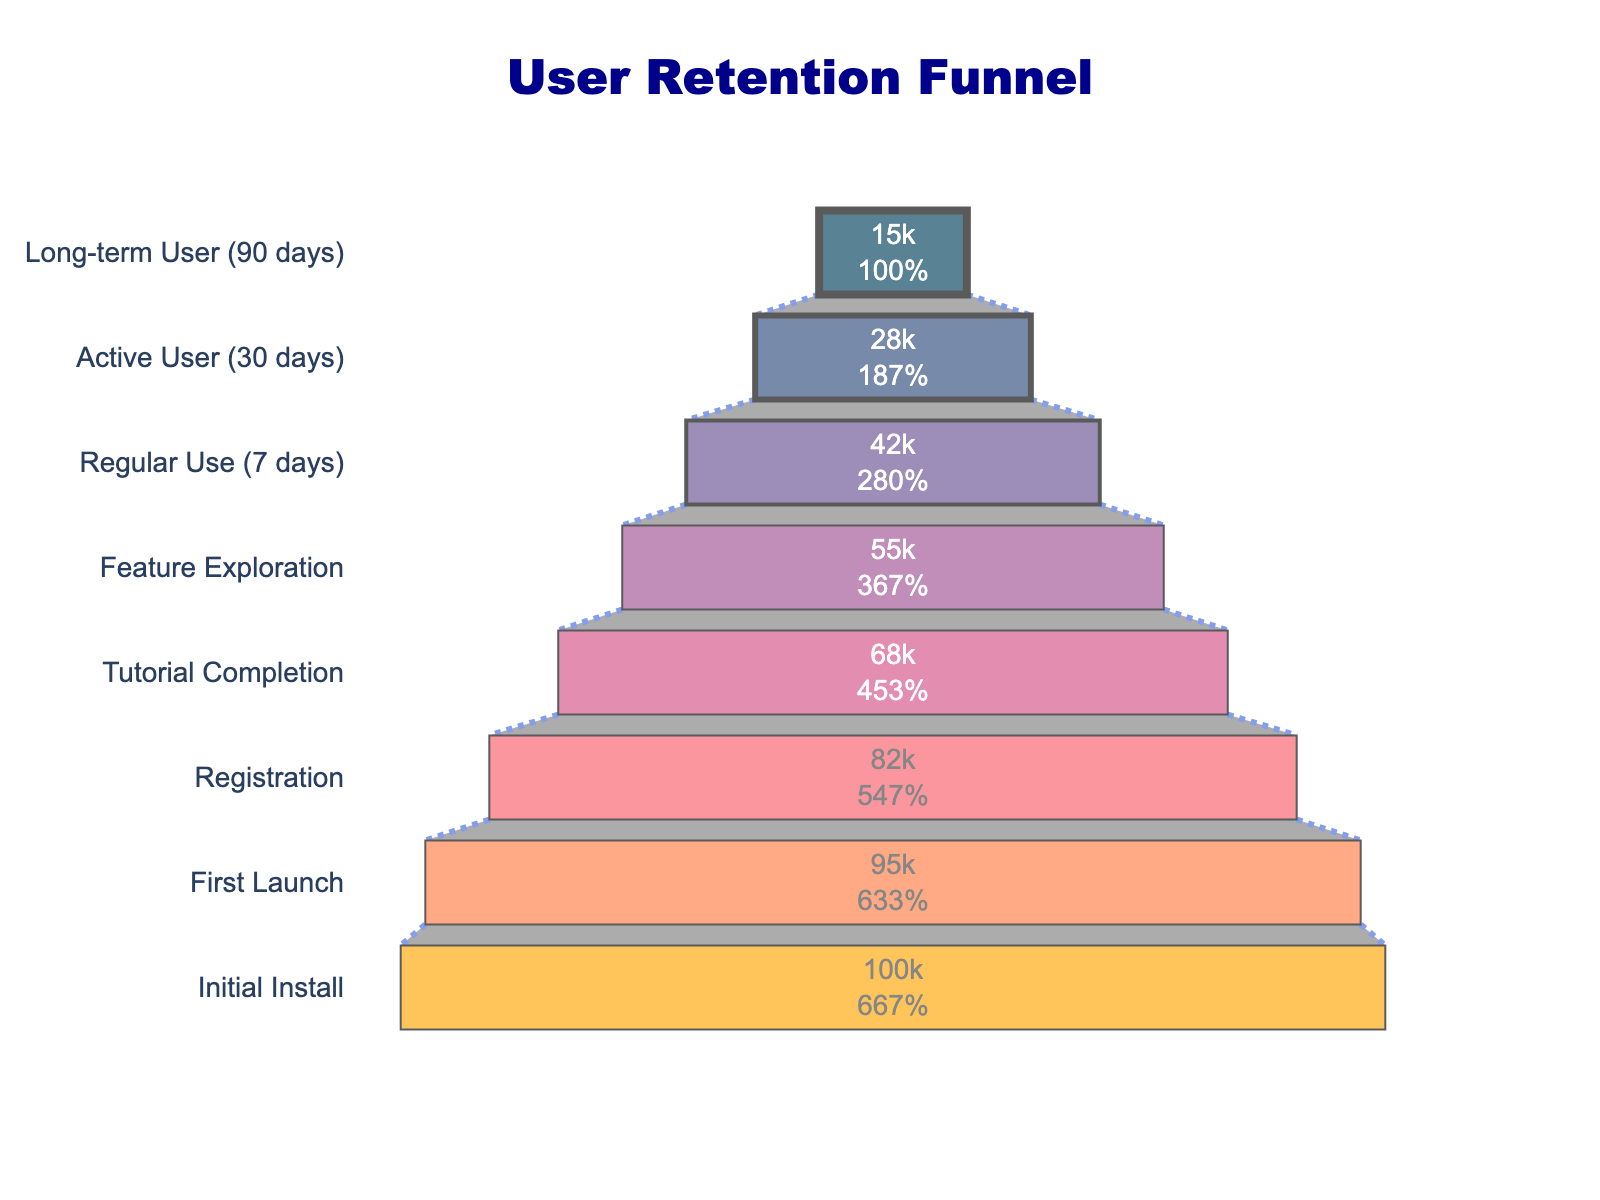How many users completed the tutorial? Locate the bar labeled "Tutorial Completion" and note the number. The figure indicates that 68,000 users completed the tutorial stage.
Answer: 68,000 What percentage of users registered after the first launch? First, find the number of users at the "First Launch" stage (95,000) and the number of users at the "Registration" stage (82,000). The percentage is calculated by (82,000 / 95,000) * 100%. This results in approximately 86.3%.
Answer: 86.3% How many users did not progress from Regular Use (7 days) to Active User (30 days)? Find the number of users at "Regular Use (7 days)" (42,000) and at "Active User (30 days)" (28,000). The difference between these two numbers is 42,000 - 28,000 = 14,000.
Answer: 14,000 Which stage has the highest user drop-off compared to the previous stage? Calculate the differences between each successive stage and find the largest difference. The values are:
Initial Install to First Launch: 5,000 
First Launch to Registration: 13,000
Registration to Tutorial Completion: 14,000
Tutorial Completion to Feature Exploration: 13,000
Feature Exploration to Regular Use (7 days): 13,000
Regular Use (7 days) to Active User (30 days): 14,000
Active User (30 days) to Long-term User (90 days): 13,000
The highest drop-off of 14,000 users occurs twice, from Registration to Tutorial Completion and from Regular Use (7 days) to Active User (30 days).
Answer: Registration to Tutorial Completion, Regular Use (7 days) to Active User (30 days) What is the percentage retention from Active User (30 days) to Long-term User (90 days)? Note the number of users at the "Active User (30 days)" stage (28,000) and at the "Long-term User (90 days)" stage (15,000). The retention percentage is (15,000 / 28,000) * 100%. This calculation gives about 53.6%.
Answer: 53.6% What is the total number of stages shown in the funnel chart? Count the number of distinct stage names listed on the y-axis. There are eight stages in the chart.
Answer: 8 Which stage had the lowest number of users? Identify the stage name with the smallest number in the x-axis bar length. The "Long-term User (90 days)" stage has the lowest number of users, which is 15,000.
Answer: Long-term User (90 days) Calculate the percentage of users retained from Initial Install to Regular Use (7 days). Find the number of users at the "Initial Install" stage (100,000) and the "Regular Use (7 days)" stage (42,000). The retention percentage is (42,000 / 100,000) * 100%. This results in 42%.
Answer: 42% 